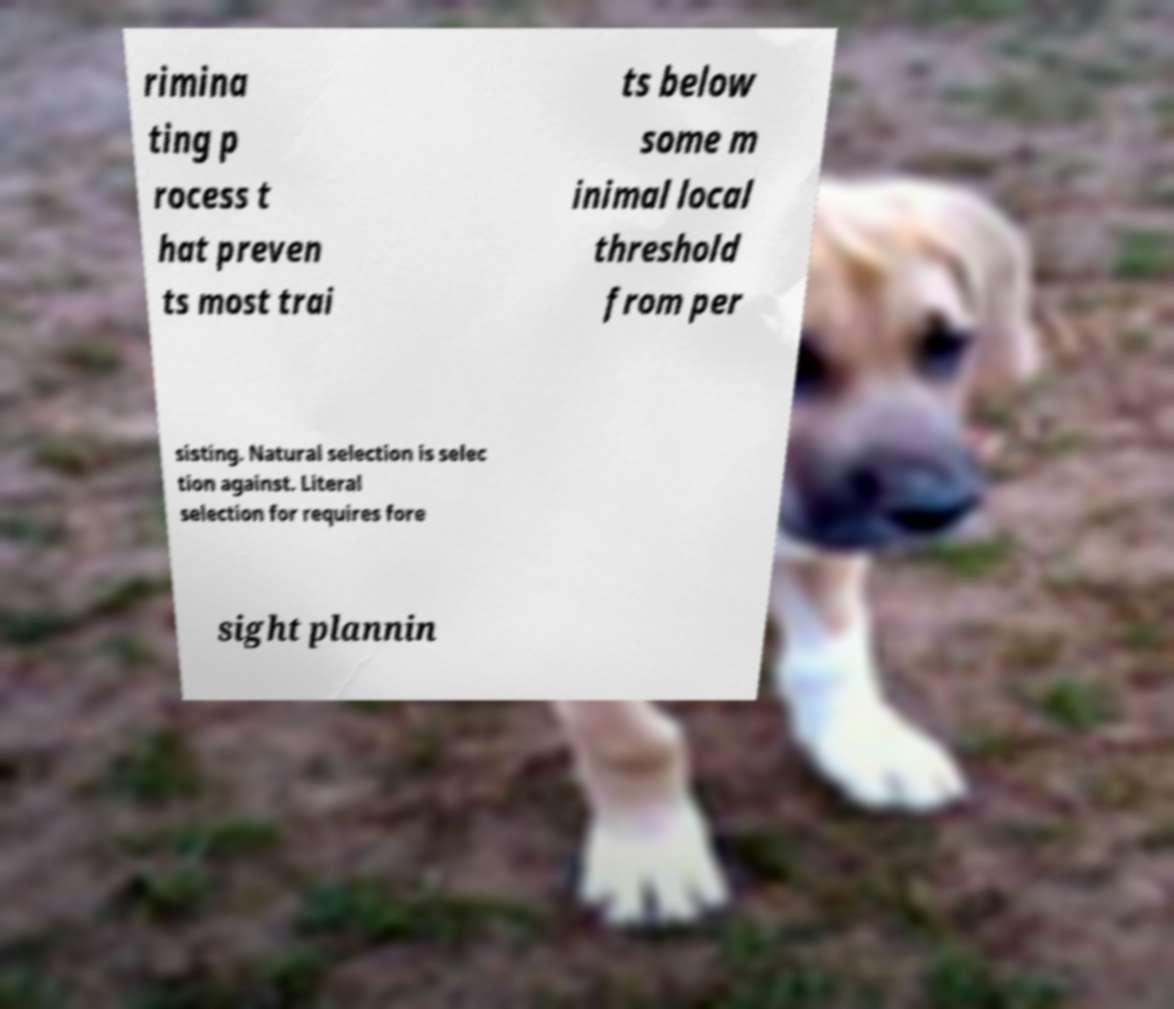For documentation purposes, I need the text within this image transcribed. Could you provide that? rimina ting p rocess t hat preven ts most trai ts below some m inimal local threshold from per sisting. Natural selection is selec tion against. Literal selection for requires fore sight plannin 